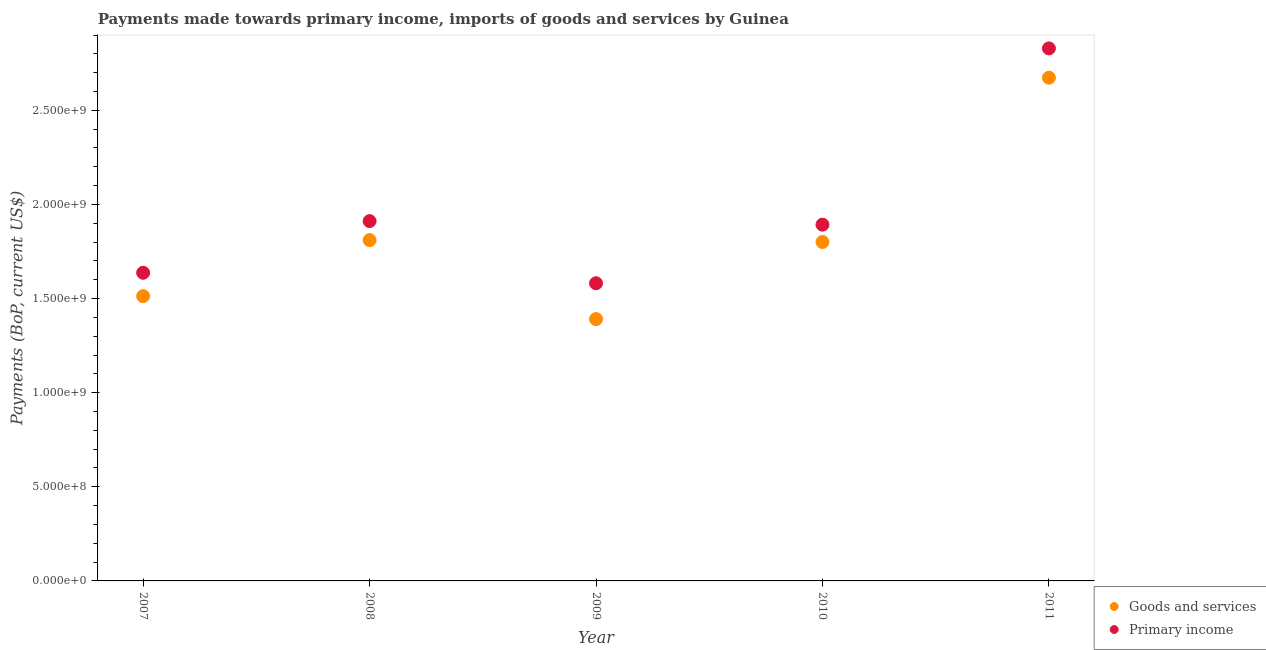What is the payments made towards primary income in 2007?
Provide a succinct answer. 1.64e+09. Across all years, what is the maximum payments made towards goods and services?
Your answer should be very brief. 2.67e+09. Across all years, what is the minimum payments made towards primary income?
Offer a very short reply. 1.58e+09. In which year was the payments made towards goods and services maximum?
Give a very brief answer. 2011. In which year was the payments made towards goods and services minimum?
Your answer should be compact. 2009. What is the total payments made towards primary income in the graph?
Provide a succinct answer. 9.85e+09. What is the difference between the payments made towards primary income in 2009 and that in 2011?
Your response must be concise. -1.25e+09. What is the difference between the payments made towards goods and services in 2008 and the payments made towards primary income in 2009?
Offer a terse response. 2.29e+08. What is the average payments made towards primary income per year?
Your answer should be very brief. 1.97e+09. In the year 2011, what is the difference between the payments made towards goods and services and payments made towards primary income?
Give a very brief answer. -1.56e+08. In how many years, is the payments made towards primary income greater than 1400000000 US$?
Your answer should be very brief. 5. What is the ratio of the payments made towards goods and services in 2007 to that in 2011?
Your answer should be compact. 0.57. Is the payments made towards goods and services in 2007 less than that in 2010?
Provide a succinct answer. Yes. What is the difference between the highest and the second highest payments made towards goods and services?
Keep it short and to the point. 8.63e+08. What is the difference between the highest and the lowest payments made towards primary income?
Provide a short and direct response. 1.25e+09. In how many years, is the payments made towards primary income greater than the average payments made towards primary income taken over all years?
Provide a short and direct response. 1. Is the sum of the payments made towards goods and services in 2010 and 2011 greater than the maximum payments made towards primary income across all years?
Make the answer very short. Yes. Is the payments made towards goods and services strictly less than the payments made towards primary income over the years?
Give a very brief answer. Yes. How many dotlines are there?
Your answer should be compact. 2. What is the difference between two consecutive major ticks on the Y-axis?
Provide a succinct answer. 5.00e+08. Are the values on the major ticks of Y-axis written in scientific E-notation?
Offer a very short reply. Yes. How many legend labels are there?
Keep it short and to the point. 2. How are the legend labels stacked?
Offer a very short reply. Vertical. What is the title of the graph?
Keep it short and to the point. Payments made towards primary income, imports of goods and services by Guinea. Does "Netherlands" appear as one of the legend labels in the graph?
Your answer should be very brief. No. What is the label or title of the Y-axis?
Make the answer very short. Payments (BoP, current US$). What is the Payments (BoP, current US$) in Goods and services in 2007?
Ensure brevity in your answer.  1.51e+09. What is the Payments (BoP, current US$) in Primary income in 2007?
Keep it short and to the point. 1.64e+09. What is the Payments (BoP, current US$) of Goods and services in 2008?
Keep it short and to the point. 1.81e+09. What is the Payments (BoP, current US$) of Primary income in 2008?
Offer a terse response. 1.91e+09. What is the Payments (BoP, current US$) in Goods and services in 2009?
Provide a short and direct response. 1.39e+09. What is the Payments (BoP, current US$) of Primary income in 2009?
Keep it short and to the point. 1.58e+09. What is the Payments (BoP, current US$) of Goods and services in 2010?
Your response must be concise. 1.80e+09. What is the Payments (BoP, current US$) in Primary income in 2010?
Offer a very short reply. 1.89e+09. What is the Payments (BoP, current US$) in Goods and services in 2011?
Provide a short and direct response. 2.67e+09. What is the Payments (BoP, current US$) in Primary income in 2011?
Provide a short and direct response. 2.83e+09. Across all years, what is the maximum Payments (BoP, current US$) in Goods and services?
Ensure brevity in your answer.  2.67e+09. Across all years, what is the maximum Payments (BoP, current US$) of Primary income?
Offer a terse response. 2.83e+09. Across all years, what is the minimum Payments (BoP, current US$) in Goods and services?
Your answer should be compact. 1.39e+09. Across all years, what is the minimum Payments (BoP, current US$) in Primary income?
Offer a very short reply. 1.58e+09. What is the total Payments (BoP, current US$) in Goods and services in the graph?
Your answer should be compact. 9.19e+09. What is the total Payments (BoP, current US$) of Primary income in the graph?
Give a very brief answer. 9.85e+09. What is the difference between the Payments (BoP, current US$) in Goods and services in 2007 and that in 2008?
Your answer should be compact. -2.98e+08. What is the difference between the Payments (BoP, current US$) in Primary income in 2007 and that in 2008?
Provide a short and direct response. -2.75e+08. What is the difference between the Payments (BoP, current US$) of Goods and services in 2007 and that in 2009?
Your answer should be very brief. 1.22e+08. What is the difference between the Payments (BoP, current US$) of Primary income in 2007 and that in 2009?
Your response must be concise. 5.57e+07. What is the difference between the Payments (BoP, current US$) in Goods and services in 2007 and that in 2010?
Make the answer very short. -2.88e+08. What is the difference between the Payments (BoP, current US$) in Primary income in 2007 and that in 2010?
Keep it short and to the point. -2.56e+08. What is the difference between the Payments (BoP, current US$) in Goods and services in 2007 and that in 2011?
Offer a very short reply. -1.16e+09. What is the difference between the Payments (BoP, current US$) in Primary income in 2007 and that in 2011?
Keep it short and to the point. -1.19e+09. What is the difference between the Payments (BoP, current US$) in Goods and services in 2008 and that in 2009?
Your answer should be very brief. 4.20e+08. What is the difference between the Payments (BoP, current US$) of Primary income in 2008 and that in 2009?
Keep it short and to the point. 3.30e+08. What is the difference between the Payments (BoP, current US$) of Goods and services in 2008 and that in 2010?
Provide a short and direct response. 9.95e+06. What is the difference between the Payments (BoP, current US$) of Primary income in 2008 and that in 2010?
Offer a very short reply. 1.90e+07. What is the difference between the Payments (BoP, current US$) in Goods and services in 2008 and that in 2011?
Offer a very short reply. -8.63e+08. What is the difference between the Payments (BoP, current US$) of Primary income in 2008 and that in 2011?
Offer a terse response. -9.17e+08. What is the difference between the Payments (BoP, current US$) in Goods and services in 2009 and that in 2010?
Offer a very short reply. -4.10e+08. What is the difference between the Payments (BoP, current US$) of Primary income in 2009 and that in 2010?
Your answer should be compact. -3.11e+08. What is the difference between the Payments (BoP, current US$) in Goods and services in 2009 and that in 2011?
Provide a succinct answer. -1.28e+09. What is the difference between the Payments (BoP, current US$) in Primary income in 2009 and that in 2011?
Your response must be concise. -1.25e+09. What is the difference between the Payments (BoP, current US$) of Goods and services in 2010 and that in 2011?
Ensure brevity in your answer.  -8.73e+08. What is the difference between the Payments (BoP, current US$) in Primary income in 2010 and that in 2011?
Your answer should be compact. -9.36e+08. What is the difference between the Payments (BoP, current US$) in Goods and services in 2007 and the Payments (BoP, current US$) in Primary income in 2008?
Your answer should be very brief. -3.99e+08. What is the difference between the Payments (BoP, current US$) in Goods and services in 2007 and the Payments (BoP, current US$) in Primary income in 2009?
Keep it short and to the point. -6.85e+07. What is the difference between the Payments (BoP, current US$) in Goods and services in 2007 and the Payments (BoP, current US$) in Primary income in 2010?
Your answer should be compact. -3.80e+08. What is the difference between the Payments (BoP, current US$) of Goods and services in 2007 and the Payments (BoP, current US$) of Primary income in 2011?
Keep it short and to the point. -1.32e+09. What is the difference between the Payments (BoP, current US$) in Goods and services in 2008 and the Payments (BoP, current US$) in Primary income in 2009?
Give a very brief answer. 2.29e+08. What is the difference between the Payments (BoP, current US$) in Goods and services in 2008 and the Payments (BoP, current US$) in Primary income in 2010?
Make the answer very short. -8.21e+07. What is the difference between the Payments (BoP, current US$) of Goods and services in 2008 and the Payments (BoP, current US$) of Primary income in 2011?
Offer a terse response. -1.02e+09. What is the difference between the Payments (BoP, current US$) in Goods and services in 2009 and the Payments (BoP, current US$) in Primary income in 2010?
Offer a terse response. -5.02e+08. What is the difference between the Payments (BoP, current US$) in Goods and services in 2009 and the Payments (BoP, current US$) in Primary income in 2011?
Make the answer very short. -1.44e+09. What is the difference between the Payments (BoP, current US$) in Goods and services in 2010 and the Payments (BoP, current US$) in Primary income in 2011?
Your answer should be compact. -1.03e+09. What is the average Payments (BoP, current US$) of Goods and services per year?
Provide a short and direct response. 1.84e+09. What is the average Payments (BoP, current US$) of Primary income per year?
Make the answer very short. 1.97e+09. In the year 2007, what is the difference between the Payments (BoP, current US$) in Goods and services and Payments (BoP, current US$) in Primary income?
Keep it short and to the point. -1.24e+08. In the year 2008, what is the difference between the Payments (BoP, current US$) of Goods and services and Payments (BoP, current US$) of Primary income?
Keep it short and to the point. -1.01e+08. In the year 2009, what is the difference between the Payments (BoP, current US$) of Goods and services and Payments (BoP, current US$) of Primary income?
Provide a short and direct response. -1.90e+08. In the year 2010, what is the difference between the Payments (BoP, current US$) of Goods and services and Payments (BoP, current US$) of Primary income?
Give a very brief answer. -9.20e+07. In the year 2011, what is the difference between the Payments (BoP, current US$) of Goods and services and Payments (BoP, current US$) of Primary income?
Ensure brevity in your answer.  -1.56e+08. What is the ratio of the Payments (BoP, current US$) in Goods and services in 2007 to that in 2008?
Your answer should be compact. 0.84. What is the ratio of the Payments (BoP, current US$) of Primary income in 2007 to that in 2008?
Offer a terse response. 0.86. What is the ratio of the Payments (BoP, current US$) in Goods and services in 2007 to that in 2009?
Make the answer very short. 1.09. What is the ratio of the Payments (BoP, current US$) of Primary income in 2007 to that in 2009?
Provide a succinct answer. 1.04. What is the ratio of the Payments (BoP, current US$) of Goods and services in 2007 to that in 2010?
Offer a very short reply. 0.84. What is the ratio of the Payments (BoP, current US$) of Primary income in 2007 to that in 2010?
Give a very brief answer. 0.86. What is the ratio of the Payments (BoP, current US$) in Goods and services in 2007 to that in 2011?
Offer a very short reply. 0.57. What is the ratio of the Payments (BoP, current US$) of Primary income in 2007 to that in 2011?
Your answer should be very brief. 0.58. What is the ratio of the Payments (BoP, current US$) of Goods and services in 2008 to that in 2009?
Keep it short and to the point. 1.3. What is the ratio of the Payments (BoP, current US$) of Primary income in 2008 to that in 2009?
Offer a terse response. 1.21. What is the ratio of the Payments (BoP, current US$) in Goods and services in 2008 to that in 2010?
Keep it short and to the point. 1.01. What is the ratio of the Payments (BoP, current US$) in Goods and services in 2008 to that in 2011?
Provide a short and direct response. 0.68. What is the ratio of the Payments (BoP, current US$) in Primary income in 2008 to that in 2011?
Your answer should be very brief. 0.68. What is the ratio of the Payments (BoP, current US$) of Goods and services in 2009 to that in 2010?
Your response must be concise. 0.77. What is the ratio of the Payments (BoP, current US$) of Primary income in 2009 to that in 2010?
Provide a succinct answer. 0.84. What is the ratio of the Payments (BoP, current US$) in Goods and services in 2009 to that in 2011?
Your answer should be compact. 0.52. What is the ratio of the Payments (BoP, current US$) in Primary income in 2009 to that in 2011?
Keep it short and to the point. 0.56. What is the ratio of the Payments (BoP, current US$) of Goods and services in 2010 to that in 2011?
Give a very brief answer. 0.67. What is the ratio of the Payments (BoP, current US$) of Primary income in 2010 to that in 2011?
Ensure brevity in your answer.  0.67. What is the difference between the highest and the second highest Payments (BoP, current US$) in Goods and services?
Provide a succinct answer. 8.63e+08. What is the difference between the highest and the second highest Payments (BoP, current US$) in Primary income?
Your answer should be compact. 9.17e+08. What is the difference between the highest and the lowest Payments (BoP, current US$) of Goods and services?
Make the answer very short. 1.28e+09. What is the difference between the highest and the lowest Payments (BoP, current US$) of Primary income?
Ensure brevity in your answer.  1.25e+09. 